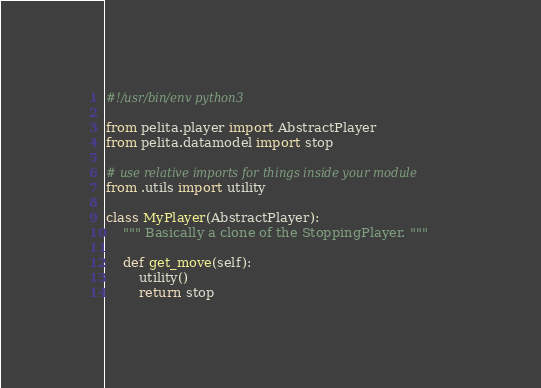Convert code to text. <code><loc_0><loc_0><loc_500><loc_500><_Python_>#!/usr/bin/env python3

from pelita.player import AbstractPlayer
from pelita.datamodel import stop

# use relative imports for things inside your module
from .utils import utility

class MyPlayer(AbstractPlayer):
    """ Basically a clone of the StoppingPlayer. """

    def get_move(self):
        utility()
        return stop
</code> 